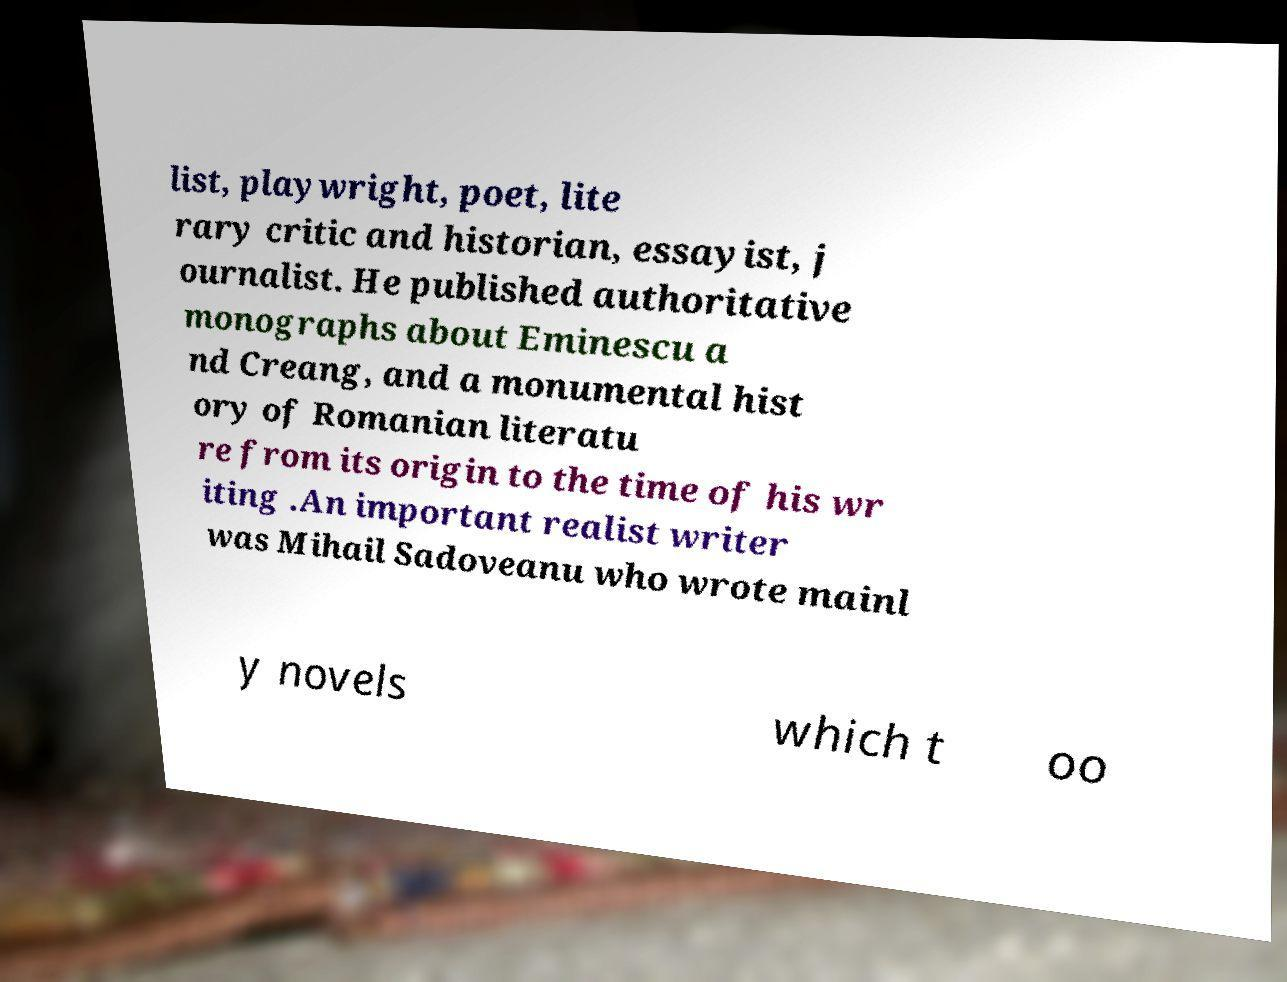Can you accurately transcribe the text from the provided image for me? list, playwright, poet, lite rary critic and historian, essayist, j ournalist. He published authoritative monographs about Eminescu a nd Creang, and a monumental hist ory of Romanian literatu re from its origin to the time of his wr iting .An important realist writer was Mihail Sadoveanu who wrote mainl y novels which t oo 